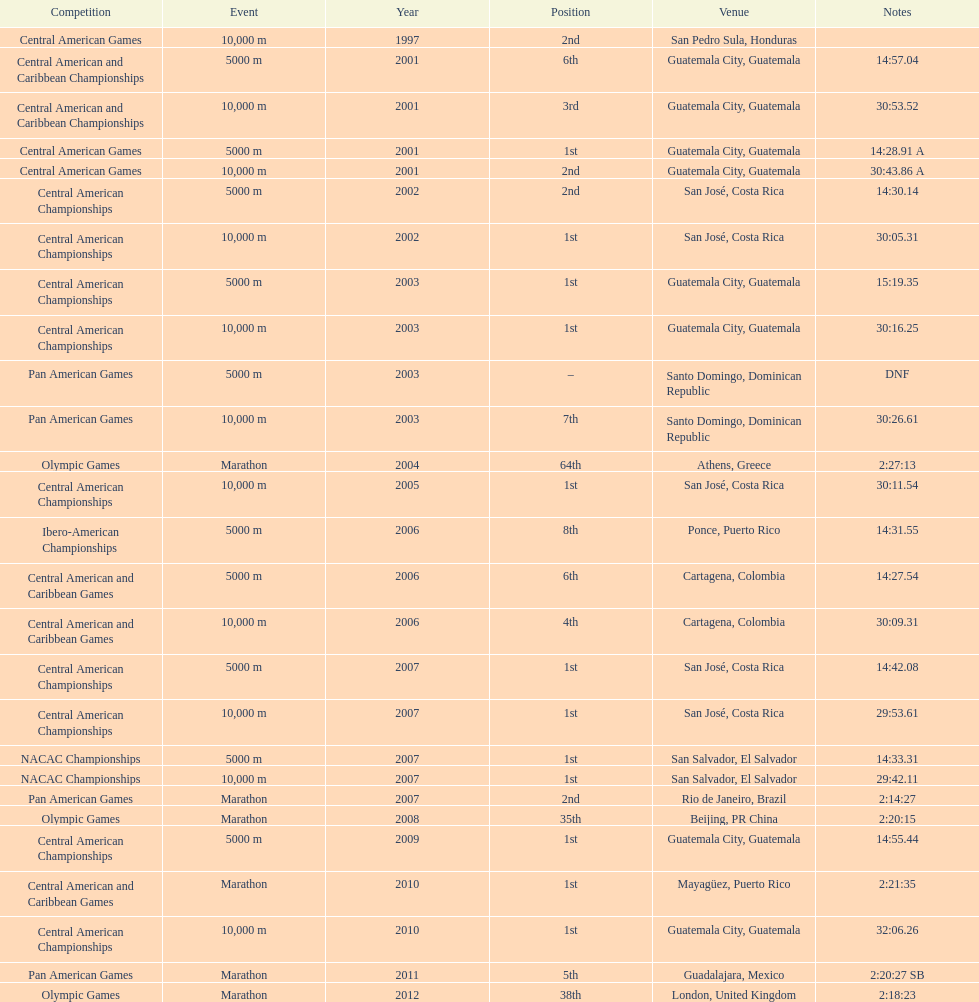Which event is listed more between the 10,000m and the 5000m? 10,000 m. 